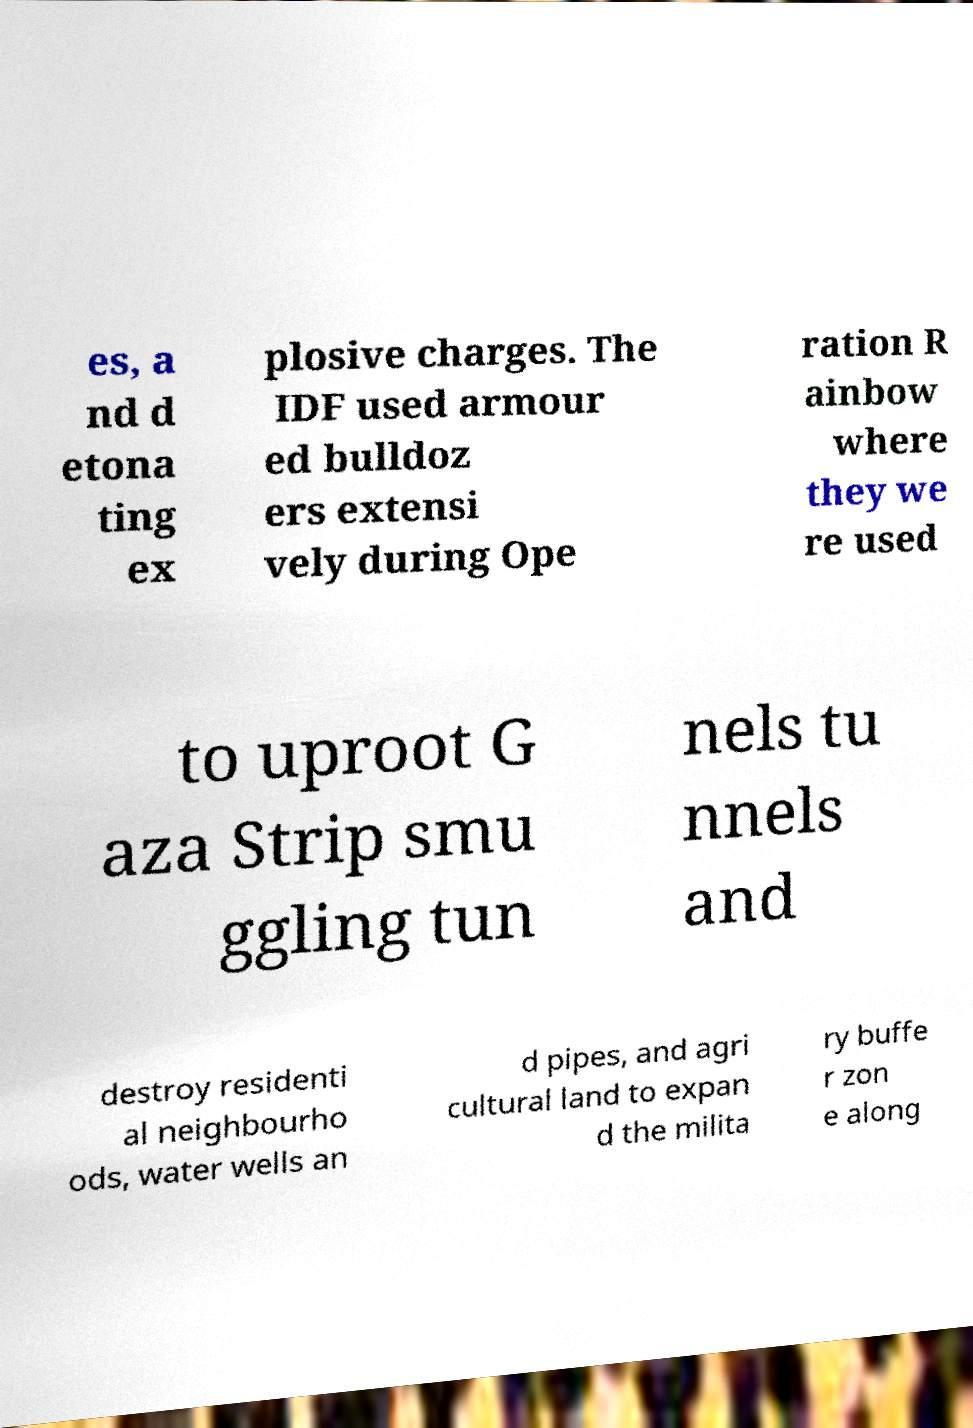Could you assist in decoding the text presented in this image and type it out clearly? es, a nd d etona ting ex plosive charges. The IDF used armour ed bulldoz ers extensi vely during Ope ration R ainbow where they we re used to uproot G aza Strip smu ggling tun nels tu nnels and destroy residenti al neighbourho ods, water wells an d pipes, and agri cultural land to expan d the milita ry buffe r zon e along 